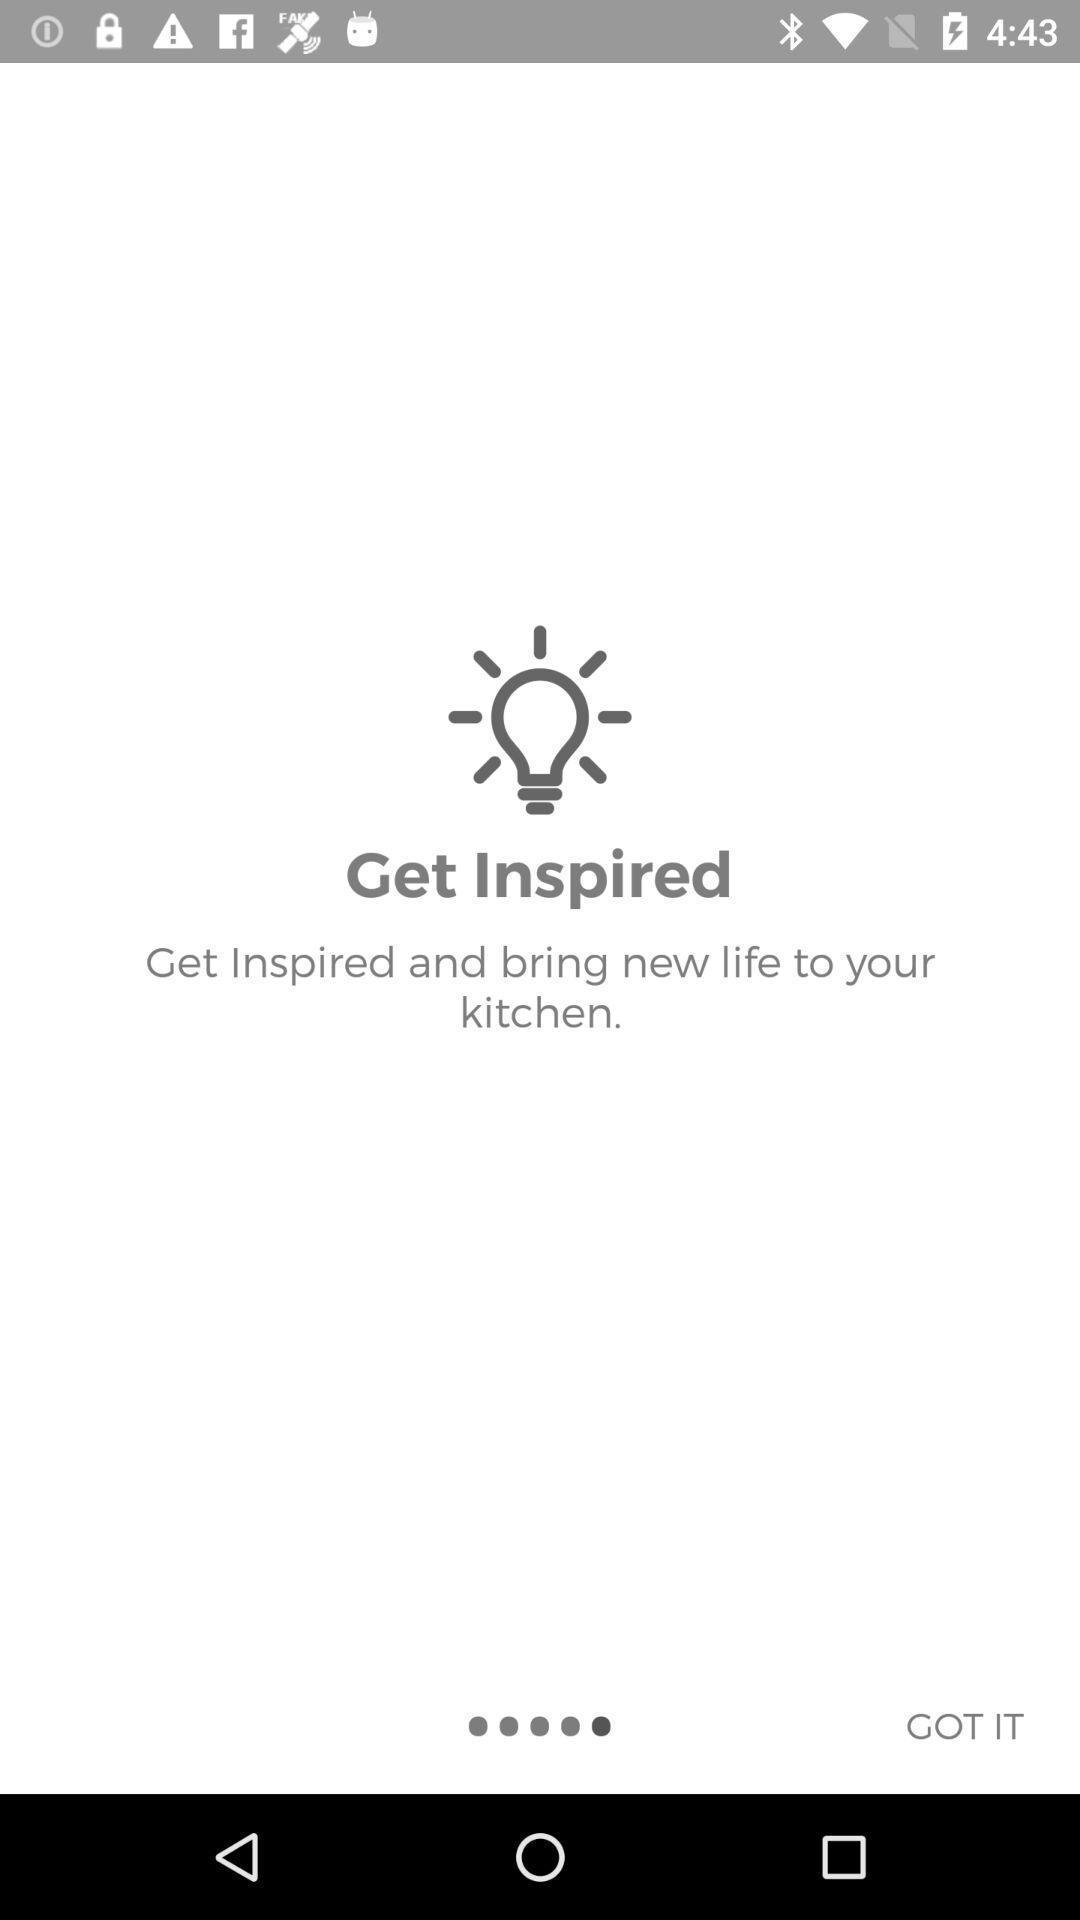What details can you identify in this image? Page displaying to get inspired with the app. 